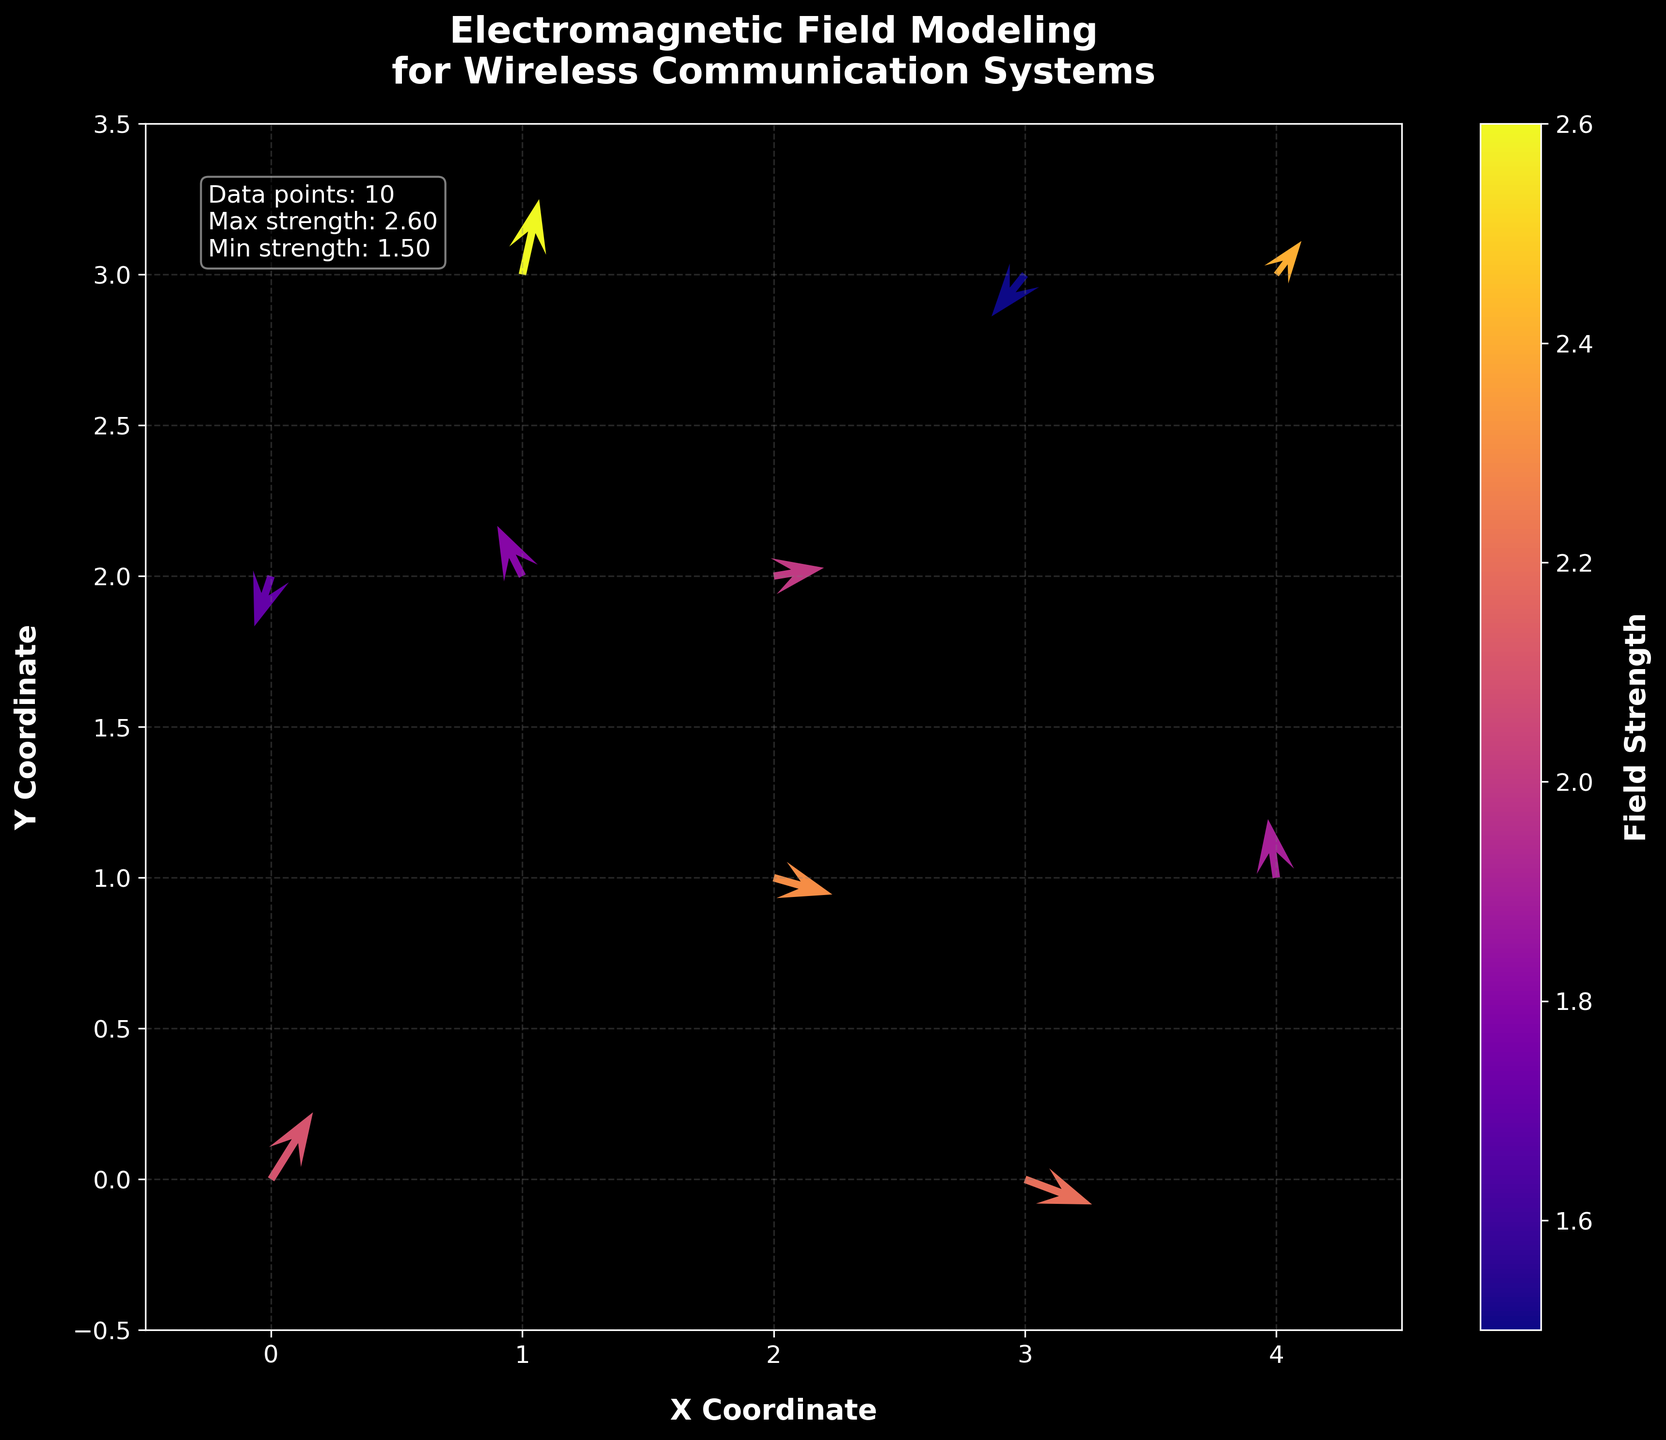What is the title of the quiver plot? The title is located at the top of the plot and describes the overall theme of the visualization.
Answer: Electromagnetic Field Modeling for Wireless Communication Systems What are the axis labels in the plot? The axis labels are found on the horizontal (x-axis) and vertical (y-axis) axes and indicate the coordinate system.
Answer: X Coordinate and Y Coordinate How many data points are shown in the plot? The text box within the plot indicates the number of data points.
Answer: 10 Which color indicates the highest field strength? The color bar on the right side of the plot shows the color gradient corresponding to field strength; the color at the top end represents the highest value.
Answer: Bright yellow What is the minimum field strength value shown in the plot? The text box within the plot provides the minimum field strength value.
Answer: 1.5 What is the direction of the vector at the (1,2) coordinate? The vector direction can be determined by its components u and v, located at (1,2).
Answer: To the left and slightly up Which coordinate has the longest vector? Find the vector with the largest length by looking at the plot and comparing the lengths visually.
Answer: (3,0) How does the vector at (2,1) compare in direction to the vector at (2,2)? Compare the directions of the vectors at these two coordinates by examining their u and v components visually on the plot.
Answer: (2,1) points up-right, (2,2) points right What is the difference in field strength between the vectors at (1,3) and (4,1)? Subtract the strength value of the vector at (4,1) from the strength value at (1,3).
Answer: 2.6 - 1.9 = 0.7 Which point has a vector that points downward? Look at the vectors in the plot and identify one with a negative v component.
Answer: (3,3) 